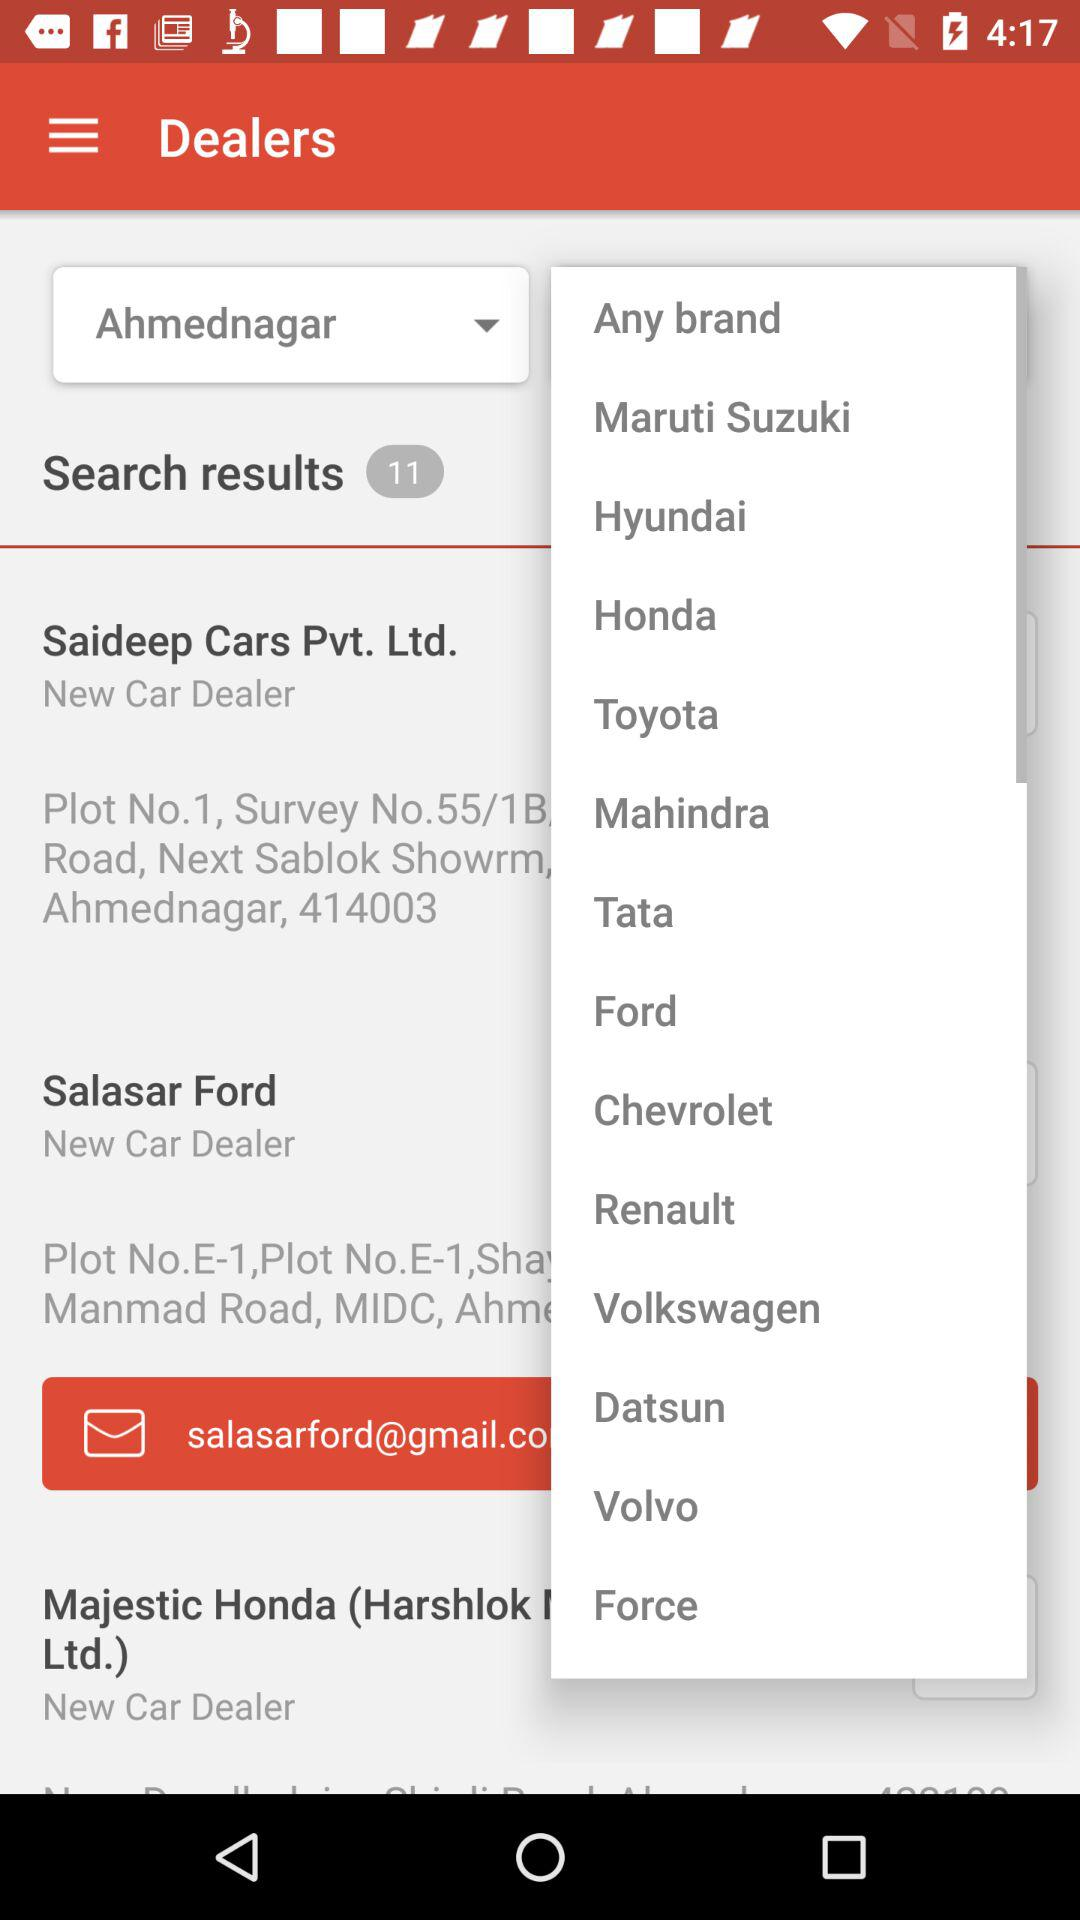What are the brand options that I can select? The brand options that you can select are "Maruti Suzuki", "Hyundai", "Honda", "Toyota", "Mahindra", "Tata", "Ford", "Chevrolet", "Renault", "Volkswagen", "Datsun", "Volvo" and "Force". 